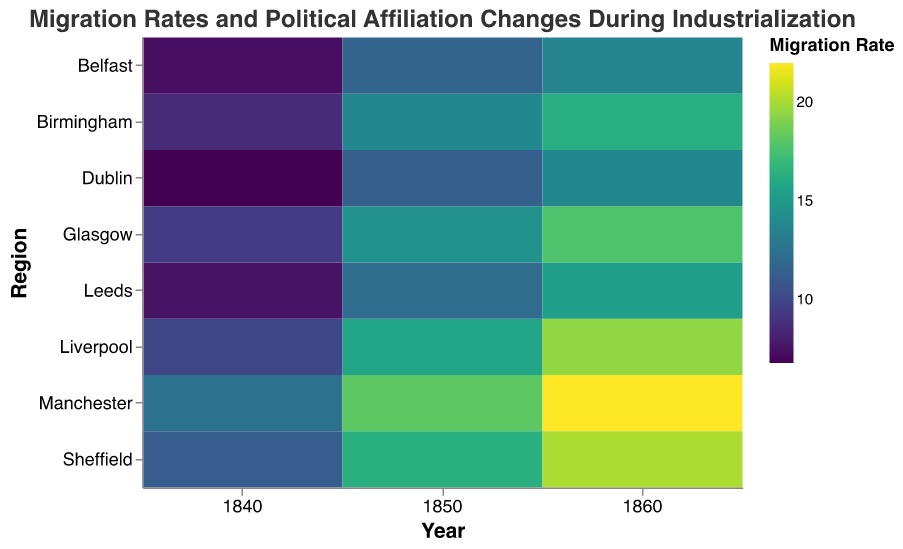What is the title of the figure? The title of a figure can usually be found at the top, typically in larger or bold text. In this case, it is specified as "Migration Rates and Political Affiliation Changes During Industrialization".
Answer: Migration Rates and Political Affiliation Changes During Industrialization Which region has the highest migration rate in 1860? To find this out, look at the color intensity for the year 1860 across all regions. The region with the darkest color represents the highest migration rate. Manchester has the darkest color in 1860.
Answer: Manchester How does the political affiliation change in Liverpool from 1840 to 1860? For this, trace the size of the colored rectangles corresponding to Liverpool from 1840 to 1860. The sizes increase from 3 to 8, showing a rising trend in political affiliation change.
Answer: It increases from 3 to 8 What is the average migration rate in 1850 across all regions? Add the migration rates for all regions in 1850: Manchester (18.2), Liverpool (15.7), Birmingham (13.9), Glasgow (14.5), Leeds (12.1), Sheffield (16.4), Dublin (11.3), Belfast (11.6). The total is 113.7. Divide by 8 (number of regions) to get the average: 113.7 / 8 = 14.21.
Answer: 14.21 Which region had the lowest migration rate in 1840? To determine this, look at the color intensity of the rectangles for the year 1840 across all regions. The lightest color represents the lowest migration rate. The lightest color corresponds to Dublin, which had the migration rate of 6.8.
Answer: Dublin Between Manchester and Sheffield, which had a greater change in migration rate from 1840 to 1860? Calculate the change in migration rate for Manchester: 22.0 - 12.5 = 9.5. For Sheffield: 20.1 - 11.2 = 8.9. Manchester's change (9.5) is greater than Sheffield's change (8.9).
Answer: Manchester How does the migration rate in Birmingham change from 1850 to 1860? Compare the migration rates for Birmingham in 1850 and 1860. The migration rate in Birmingham in 1850 is 13.9 and in 1860 it is 16.3. 16.3 - 13.9 = 2.4 is the increase in migration rate.
Answer: It increases by 2.4 What trend do you observe in political affiliation change for all regions from 1840 to 1860? To identify the trend, observe the change in the size of rectangles from 1840 to 1860 for all regions. The sizes of the rectangles increase over time for all regions, indicating an overall increasing trend in political affiliation change.
Answer: Increasing trend 